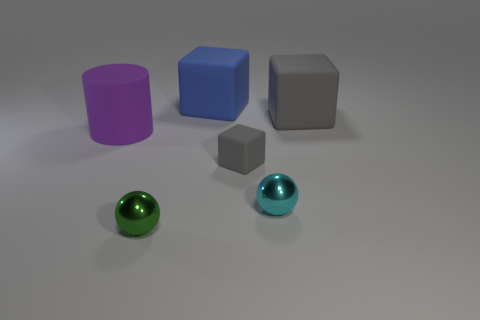Add 1 blue matte objects. How many objects exist? 7 Subtract all cylinders. How many objects are left? 5 Add 2 small cyan shiny things. How many small cyan shiny things exist? 3 Subtract 0 brown spheres. How many objects are left? 6 Subtract all tiny blue rubber things. Subtract all small green metal balls. How many objects are left? 5 Add 3 big blue objects. How many big blue objects are left? 4 